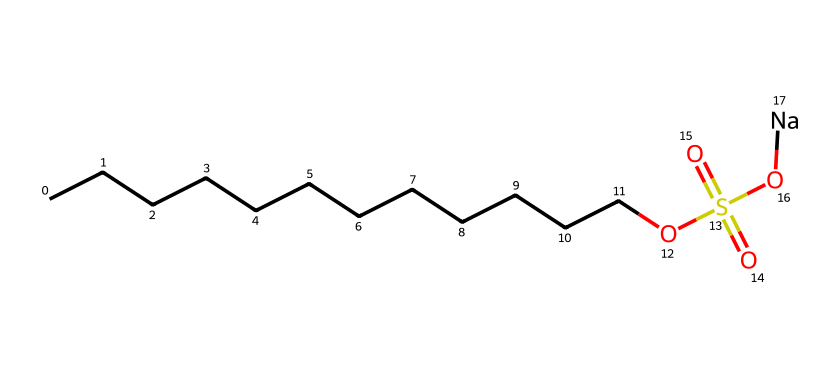What is the molecular formula of sodium lauryl sulfate? The SMILES representation indicates the presence of 12 carbon (C) atoms, 25 hydrogen (H) atoms, 1 sulfur (S) atom, 4 oxygen (O) atoms, and 1 sodium (Na) atom. Thus, combining these elements gives us the molecular formula C12H25NaO4S.
Answer: C12H25NaO4S How many carbon atoms are in the structure? By analyzing the SMILES notation, we count the "C" that indicates carbon atoms. There are 12 "C"s in the long hydrocarbon chain represented before the "O" and the sulfonate group.
Answer: 12 What type of chemical bond is primarily found in the hydrocarbon chain of sodium lauryl sulfate? The hydrocarbon chain consists of carbon atoms bonded to hydrogen atoms primarily through single covalent bonds, which are the typical bonds found in aliphatic hydrocarbons.
Answer: single covalent What functional group is indicated by the "OS(=O)(=O)O" portion of the SMILES? The presence of "S(=O)(=O)" indicates a sulfonate group, specifically a sulfate group where sulfur is bonded to four oxygen atoms, three of which are double-bonded and one single-bonded to oxygen, indicating a sulfonic acid derivative.
Answer: sulfate What role does sodium lauryl sulfate play in shampoos and cleansers? Sodium lauryl sulfate is primarily used as a surfactant, which helps to lower the surface tension between different substances, allowing for better spreading and mixing of ingredients as well as aiding in the emulsification and foaming processes in cleansers.
Answer: surfactant Which part of the molecule provides its hydrophilic properties? The sulfate group ("OS(=O)(=O)O") contains polar bonds and is charged, making this part of the molecule hydrophilic, allowing it to interact with water efficiently.
Answer: sulfate group How does the length of the hydrocarbon chain affect the properties of sodium lauryl sulfate? The length of the hydrocarbon chain affects the hydrophobicity of the molecule; longer chains generally increase the ability of the surfactant to form micelles and enhance cleansing properties, whereas shorter chains might lead to less foaming and cleaning efficiency.
Answer: increases cleansing properties 